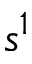Convert formula to latex. <formula><loc_0><loc_0><loc_500><loc_500>s ^ { 1 }</formula> 